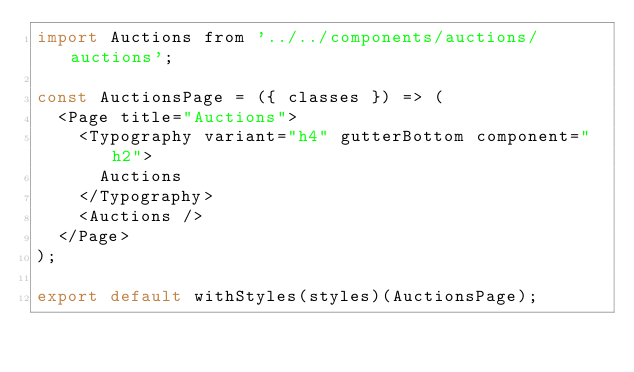<code> <loc_0><loc_0><loc_500><loc_500><_JavaScript_>import Auctions from '../../components/auctions/auctions';

const AuctionsPage = ({ classes }) => (
  <Page title="Auctions">
    <Typography variant="h4" gutterBottom component="h2">
      Auctions
    </Typography>
    <Auctions />
  </Page>
);

export default withStyles(styles)(AuctionsPage);
</code> 